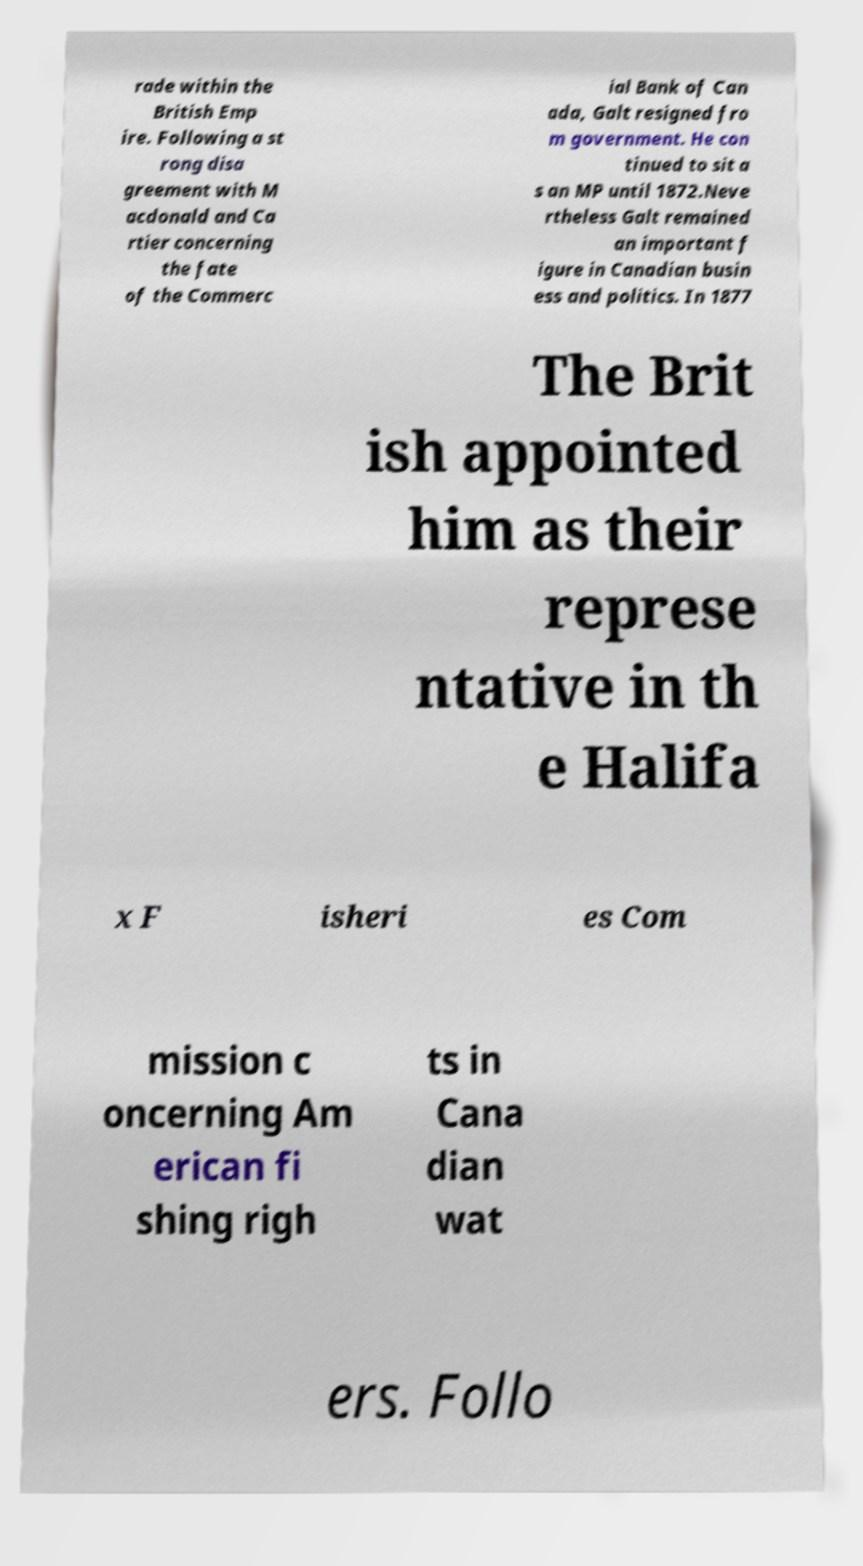What messages or text are displayed in this image? I need them in a readable, typed format. rade within the British Emp ire. Following a st rong disa greement with M acdonald and Ca rtier concerning the fate of the Commerc ial Bank of Can ada, Galt resigned fro m government. He con tinued to sit a s an MP until 1872.Neve rtheless Galt remained an important f igure in Canadian busin ess and politics. In 1877 The Brit ish appointed him as their represe ntative in th e Halifa x F isheri es Com mission c oncerning Am erican fi shing righ ts in Cana dian wat ers. Follo 